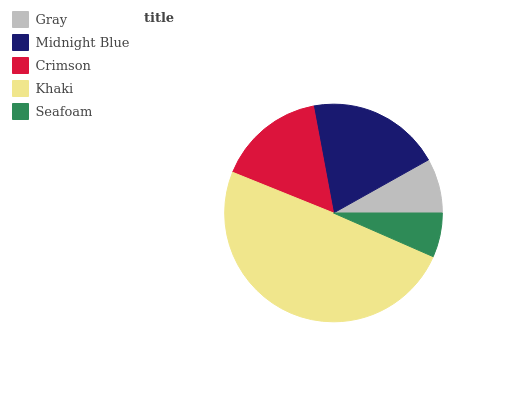Is Seafoam the minimum?
Answer yes or no. Yes. Is Khaki the maximum?
Answer yes or no. Yes. Is Midnight Blue the minimum?
Answer yes or no. No. Is Midnight Blue the maximum?
Answer yes or no. No. Is Midnight Blue greater than Gray?
Answer yes or no. Yes. Is Gray less than Midnight Blue?
Answer yes or no. Yes. Is Gray greater than Midnight Blue?
Answer yes or no. No. Is Midnight Blue less than Gray?
Answer yes or no. No. Is Crimson the high median?
Answer yes or no. Yes. Is Crimson the low median?
Answer yes or no. Yes. Is Khaki the high median?
Answer yes or no. No. Is Seafoam the low median?
Answer yes or no. No. 